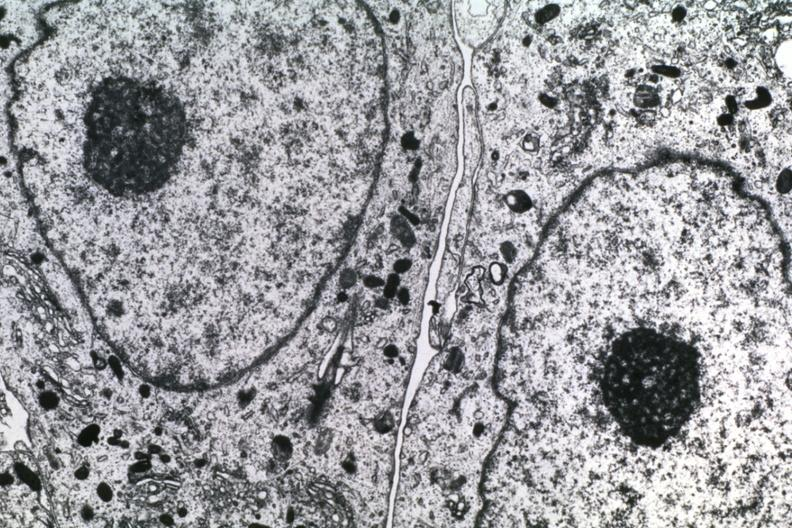s alpha smooth muscle actin immunohistochemical present?
Answer the question using a single word or phrase. No 